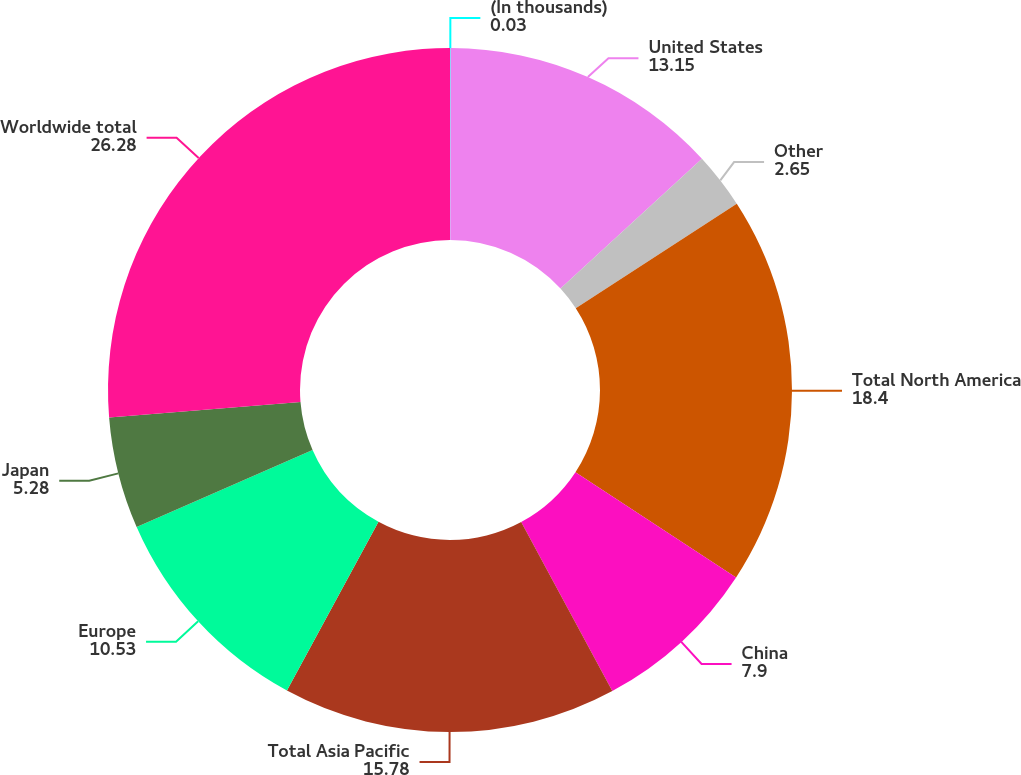<chart> <loc_0><loc_0><loc_500><loc_500><pie_chart><fcel>(In thousands)<fcel>United States<fcel>Other<fcel>Total North America<fcel>China<fcel>Total Asia Pacific<fcel>Europe<fcel>Japan<fcel>Worldwide total<nl><fcel>0.03%<fcel>13.15%<fcel>2.65%<fcel>18.4%<fcel>7.9%<fcel>15.78%<fcel>10.53%<fcel>5.28%<fcel>26.28%<nl></chart> 